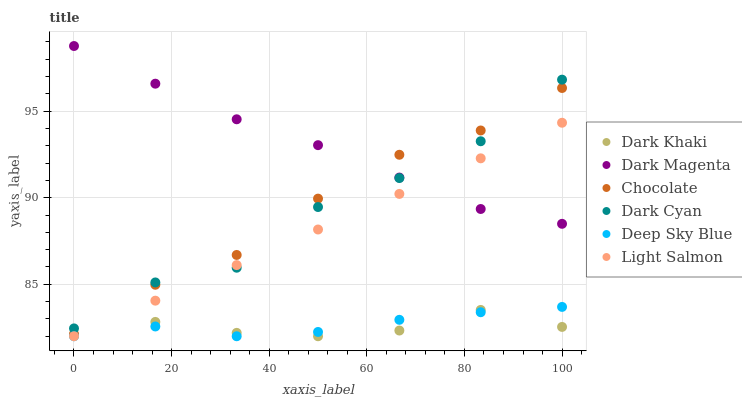Does Dark Khaki have the minimum area under the curve?
Answer yes or no. Yes. Does Dark Magenta have the maximum area under the curve?
Answer yes or no. Yes. Does Chocolate have the minimum area under the curve?
Answer yes or no. No. Does Chocolate have the maximum area under the curve?
Answer yes or no. No. Is Light Salmon the smoothest?
Answer yes or no. Yes. Is Dark Cyan the roughest?
Answer yes or no. Yes. Is Dark Magenta the smoothest?
Answer yes or no. No. Is Dark Magenta the roughest?
Answer yes or no. No. Does Light Salmon have the lowest value?
Answer yes or no. Yes. Does Chocolate have the lowest value?
Answer yes or no. No. Does Dark Magenta have the highest value?
Answer yes or no. Yes. Does Chocolate have the highest value?
Answer yes or no. No. Is Deep Sky Blue less than Dark Cyan?
Answer yes or no. Yes. Is Chocolate greater than Dark Khaki?
Answer yes or no. Yes. Does Dark Magenta intersect Light Salmon?
Answer yes or no. Yes. Is Dark Magenta less than Light Salmon?
Answer yes or no. No. Is Dark Magenta greater than Light Salmon?
Answer yes or no. No. Does Deep Sky Blue intersect Dark Cyan?
Answer yes or no. No. 